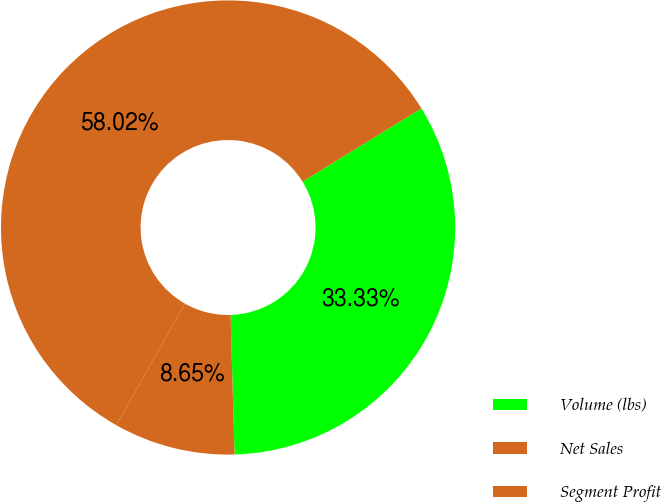Convert chart to OTSL. <chart><loc_0><loc_0><loc_500><loc_500><pie_chart><fcel>Volume (lbs)<fcel>Net Sales<fcel>Segment Profit<nl><fcel>33.33%<fcel>58.02%<fcel>8.65%<nl></chart> 